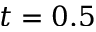Convert formula to latex. <formula><loc_0><loc_0><loc_500><loc_500>t = 0 . 5</formula> 